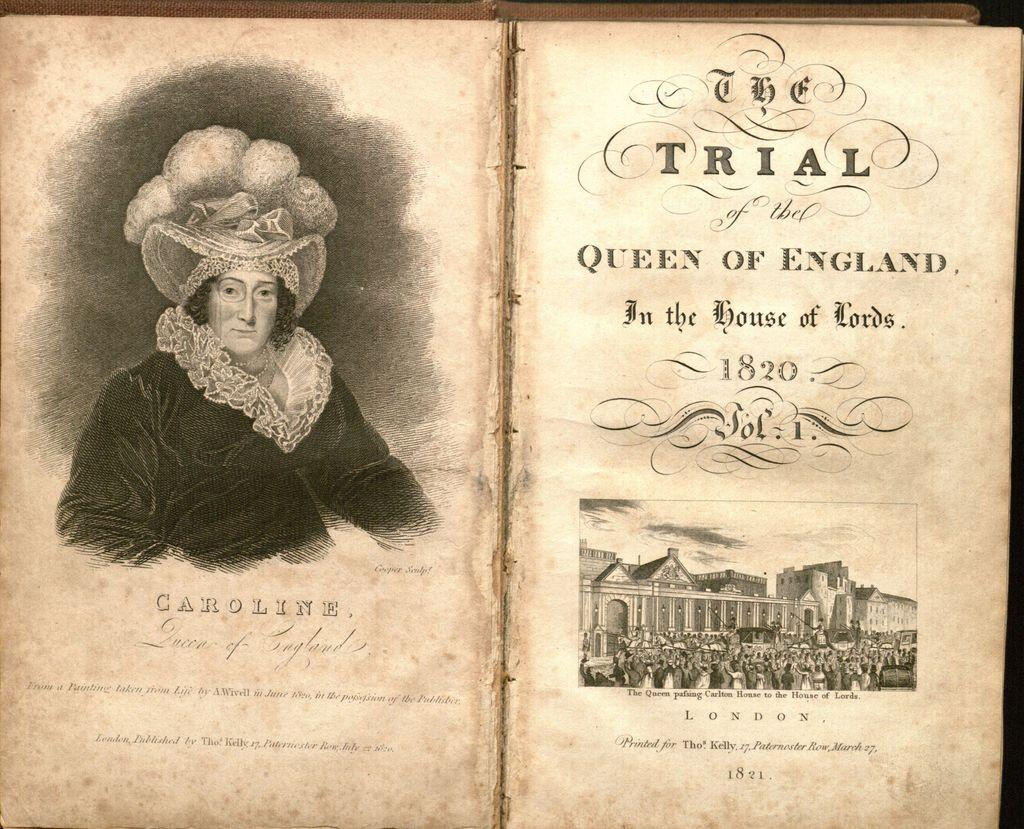<image>
Relay a brief, clear account of the picture shown. A faded old book called The Trial of the Queen of England dated 1820. 